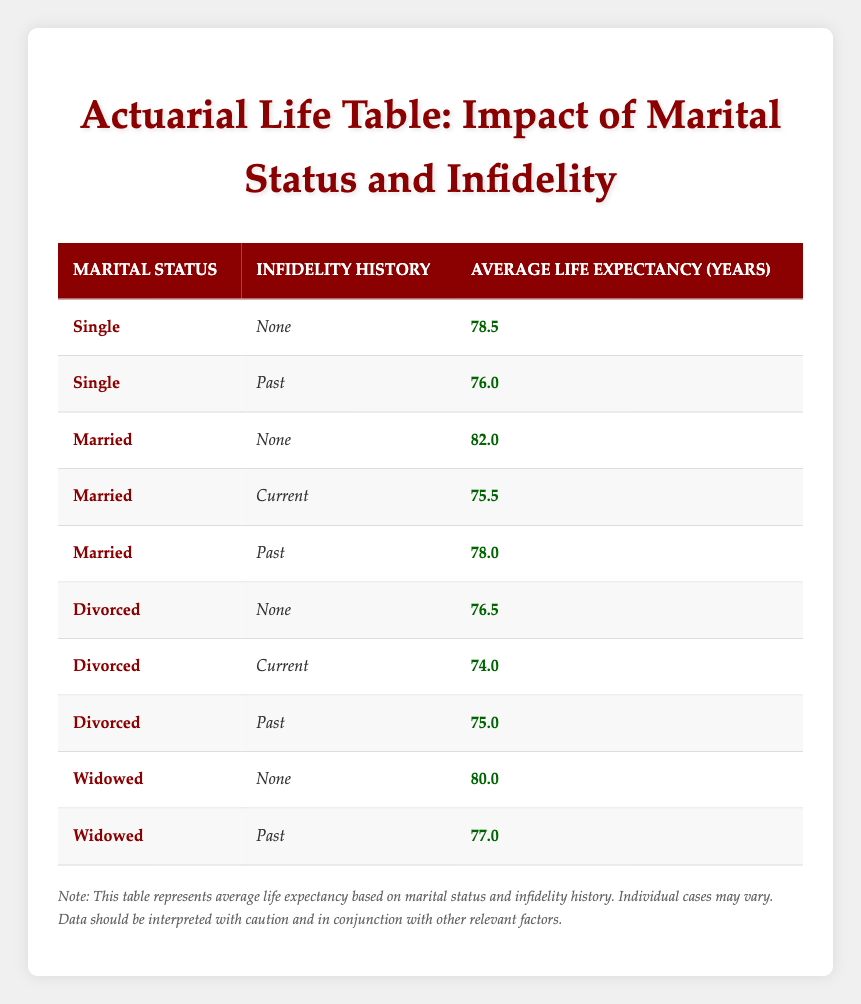What is the average life expectancy for married individuals without a history of infidelity? The table indicates that the average life expectancy for married individuals with no infidelity history is 82.0 years.
Answer: 82.0 How much shorter is the average life expectancy for divorced individuals with a current infidelity history compared to those with no infidelity history? For divorced individuals without infidelity history, the average life expectancy is 76.5 years, while for those with current infidelity it is 74.0 years. The difference is 76.5 - 74.0 = 2.5 years.
Answer: 2.5 years Is the average life expectancy for single individuals with a past infidelity history higher than that of divorced individuals with a current infidelity history? The average life expectancy for single individuals with past infidelity is 76.0 years, while for divorced individuals with current infidelity it's 74.0 years. Since 76.0 is greater than 74.0, the statement is true.
Answer: Yes How does the average life expectancy for married individuals with a current infidelity history compare to that of married individuals with a past infidelity history? The average life expectancy for married individuals with current infidelity is 75.5 years, while for those with past infidelity it is 78.0 years. Thus, married individuals with current infidelity have a shorter average life expectancy by 78.0 - 75.5 = 2.5 years.
Answer: 2.5 years shorter Which group has the highest average life expectancy: widowed individuals with no infidelity history or married individuals with no infidelity history? Widowed individuals with no infidelity history have an average life expectancy of 80.0 years, while married individuals with no infidelity history have 82.0 years. Therefore, married individuals have a higher average life expectancy.
Answer: Married individuals What is the average life expectancy for single individuals and how does it compare to that of divorced individuals with past infidelity? Single individuals have an average life expectancy of 76.0 years, while divorced individuals with past infidelity have an average of 75.0 years. Therefore, single individuals have a higher life expectancy by 76.0 - 75.0 = 1.0 year.
Answer: 1.0 year higher For widowed individuals, is there a difference in life expectancy if they have a past history of infidelity? Widowed individuals without infidelity have an average life expectancy of 80.0 years, while those with past infidelity have an average of 77.0 years. There is a difference of 80.0 - 77.0 = 3.0 years. Therefore, a history of past infidelity results in shorter life expectancy for widowed individuals.
Answer: Yes, 3.0 years shorter What is the lowest average life expectancy recorded in the table? The table shows that the lowest average life expectancy is 74.0 years for divorced individuals with a current infidelity history.
Answer: 74.0 years 